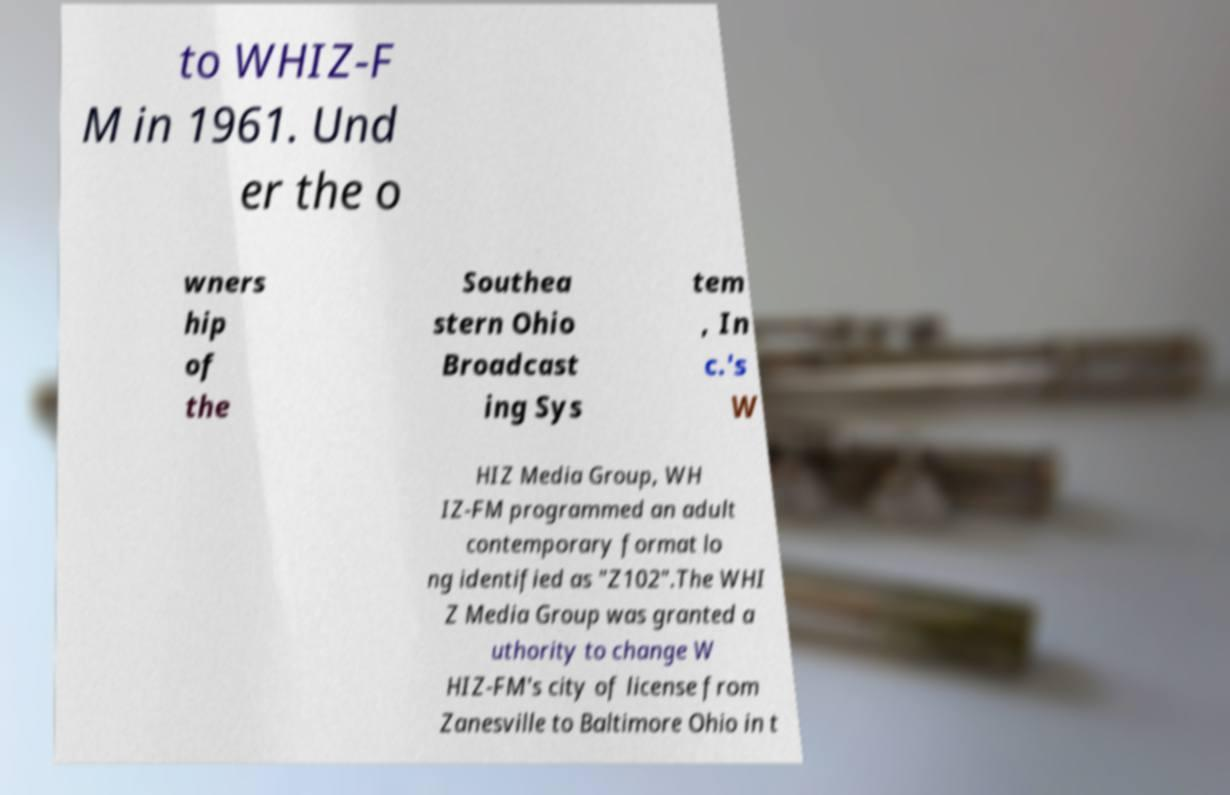Please identify and transcribe the text found in this image. to WHIZ-F M in 1961. Und er the o wners hip of the Southea stern Ohio Broadcast ing Sys tem , In c.'s W HIZ Media Group, WH IZ-FM programmed an adult contemporary format lo ng identified as "Z102".The WHI Z Media Group was granted a uthority to change W HIZ-FM's city of license from Zanesville to Baltimore Ohio in t 